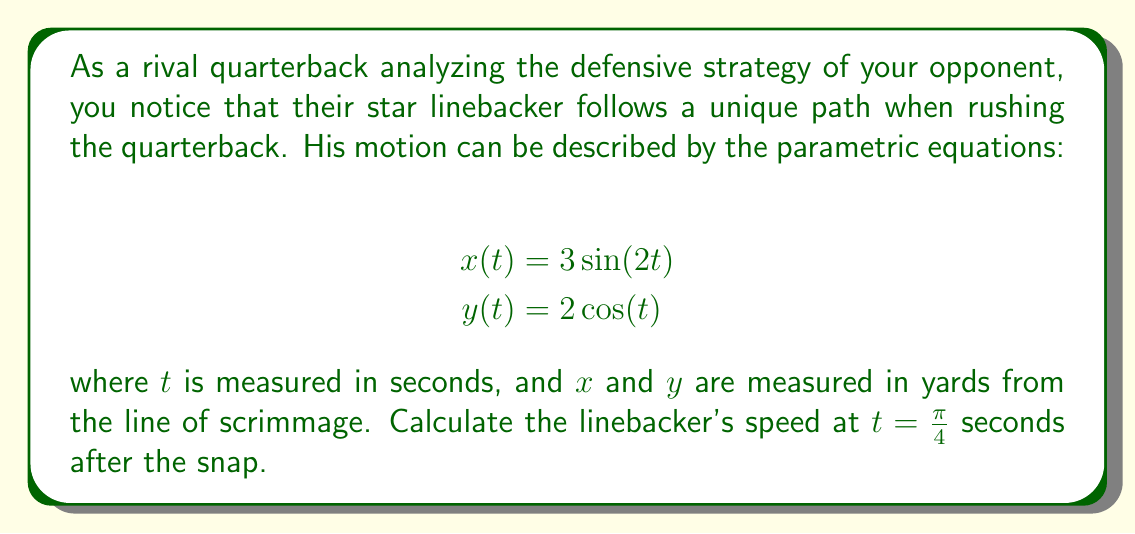Can you answer this question? To solve this problem, we need to follow these steps:

1) The speed of the linebacker at any given time can be calculated using the formula:

   $$v(t) = \sqrt{\left(\frac{dx}{dt}\right)^2 + \left(\frac{dy}{dt}\right)^2}$$

2) First, let's find $\frac{dx}{dt}$:
   $$\frac{dx}{dt} = 3 \cdot 2 \cos(2t) = 6\cos(2t)$$

3) Now, let's find $\frac{dy}{dt}$:
   $$\frac{dy}{dt} = -2\sin(t)$$

4) Substituting these into our speed formula:

   $$v(t) = \sqrt{(6\cos(2t))^2 + (-2\sin(t))^2}$$

5) Now, we need to evaluate this at $t = \frac{\pi}{4}$:

   $$v(\frac{\pi}{4}) = \sqrt{(6\cos(\frac{\pi}{2}))^2 + (-2\sin(\frac{\pi}{4}))^2}$$

6) Simplify:
   $$\cos(\frac{\pi}{2}) = 0$$
   $$\sin(\frac{\pi}{4}) = \frac{\sqrt{2}}{2}$$

   So:
   $$v(\frac{\pi}{4}) = \sqrt{(6 \cdot 0)^2 + (-2 \cdot \frac{\sqrt{2}}{2})^2}$$

7) Further simplification:
   $$v(\frac{\pi}{4}) = \sqrt{0^2 + (-\sqrt{2})^2} = \sqrt{2}$$

8) Therefore, the speed of the linebacker at $t = \frac{\pi}{4}$ seconds is $\sqrt{2}$ yards per second.
Answer: $\sqrt{2}$ yards per second 